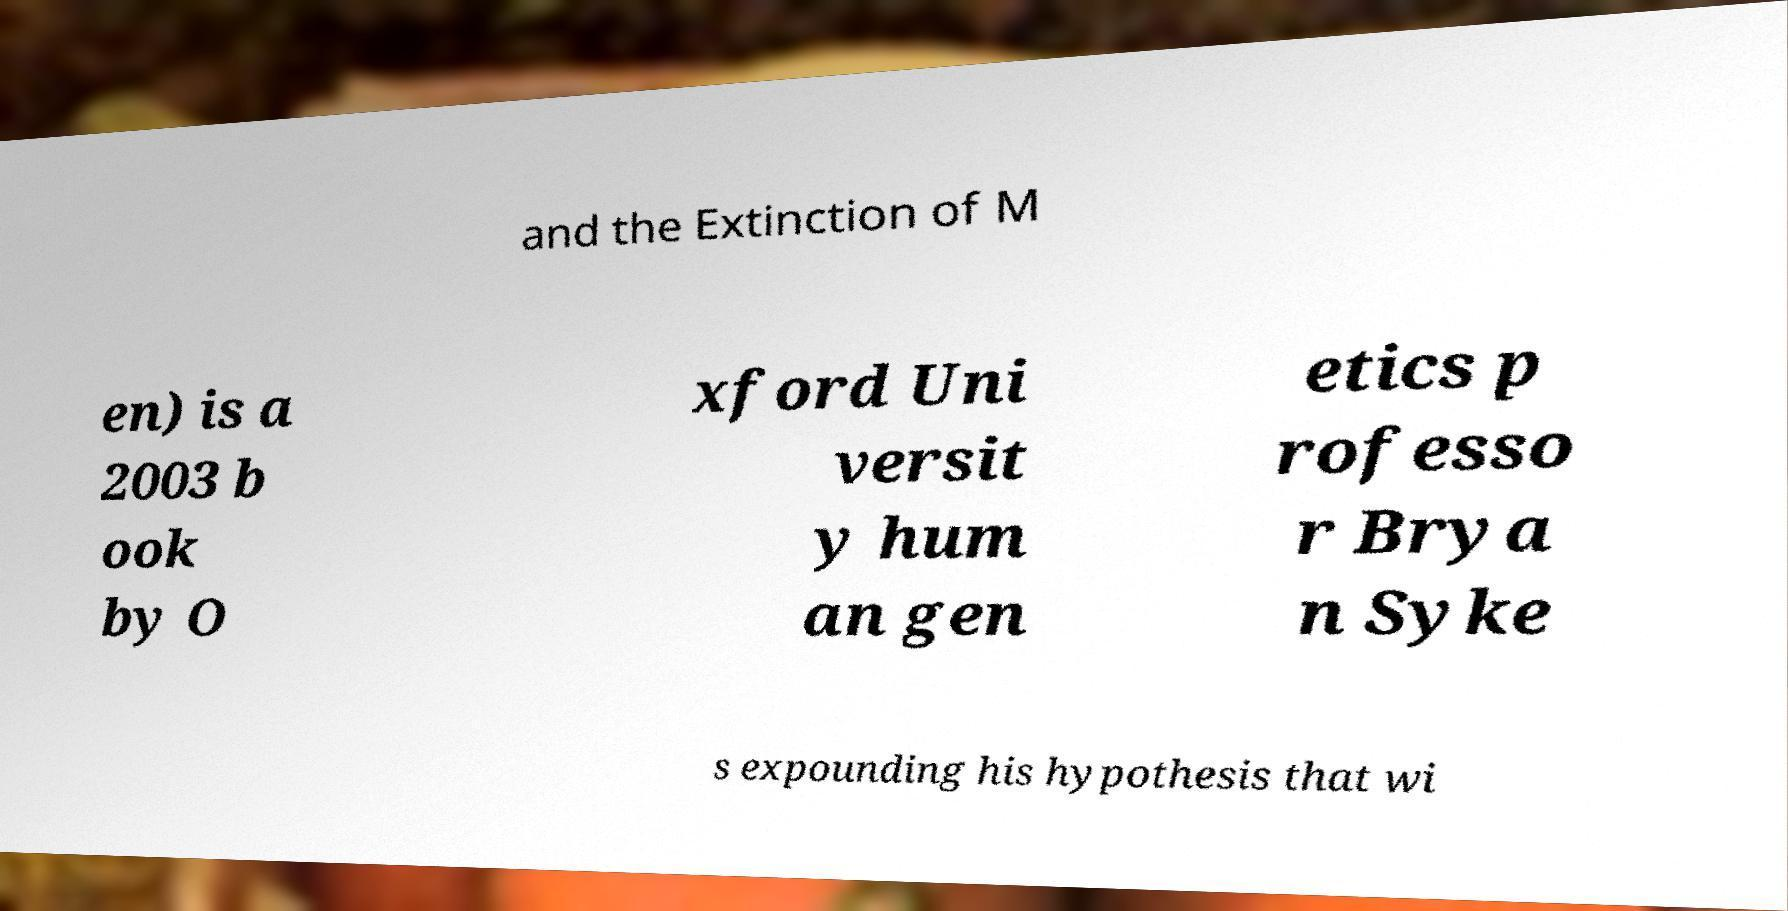Could you extract and type out the text from this image? and the Extinction of M en) is a 2003 b ook by O xford Uni versit y hum an gen etics p rofesso r Brya n Syke s expounding his hypothesis that wi 